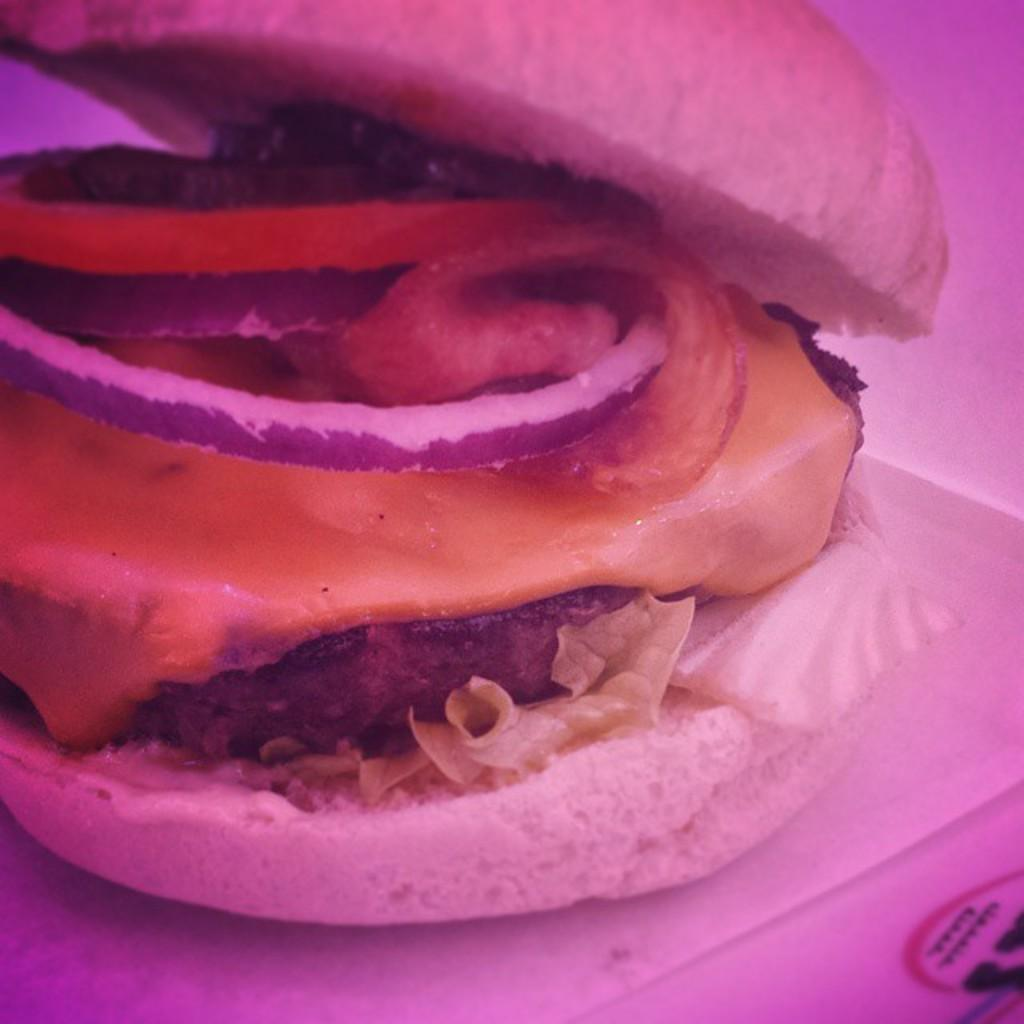What type of food is shown in the image? There is a hamburger in the image. Where is the hamburger located? The hamburger is on a surface. What ingredients are visible in the hamburger? The hamburger contains cheese, onion slices, and tomato slices. Can you find the receipt for the hamburger in the image? There is no receipt present in the image; it only shows the hamburger on a surface. What type of office is shown in the image? There is no office present in the image; it only shows a hamburger on a surface. 